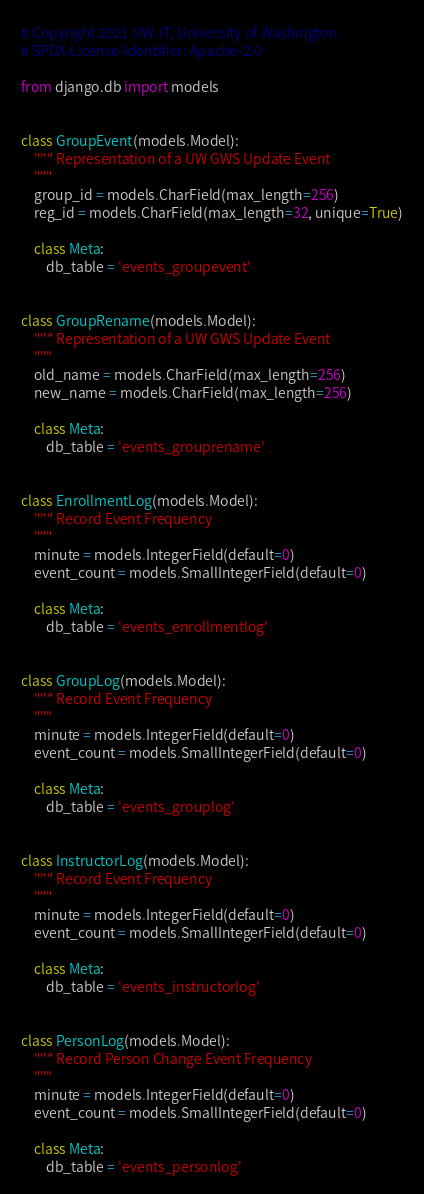<code> <loc_0><loc_0><loc_500><loc_500><_Python_># Copyright 2021 UW-IT, University of Washington
# SPDX-License-Identifier: Apache-2.0

from django.db import models


class GroupEvent(models.Model):
    """ Representation of a UW GWS Update Event
    """
    group_id = models.CharField(max_length=256)
    reg_id = models.CharField(max_length=32, unique=True)

    class Meta:
        db_table = 'events_groupevent'


class GroupRename(models.Model):
    """ Representation of a UW GWS Update Event
    """
    old_name = models.CharField(max_length=256)
    new_name = models.CharField(max_length=256)

    class Meta:
        db_table = 'events_grouprename'


class EnrollmentLog(models.Model):
    """ Record Event Frequency
    """
    minute = models.IntegerField(default=0)
    event_count = models.SmallIntegerField(default=0)

    class Meta:
        db_table = 'events_enrollmentlog'


class GroupLog(models.Model):
    """ Record Event Frequency
    """
    minute = models.IntegerField(default=0)
    event_count = models.SmallIntegerField(default=0)

    class Meta:
        db_table = 'events_grouplog'


class InstructorLog(models.Model):
    """ Record Event Frequency
    """
    minute = models.IntegerField(default=0)
    event_count = models.SmallIntegerField(default=0)

    class Meta:
        db_table = 'events_instructorlog'


class PersonLog(models.Model):
    """ Record Person Change Event Frequency
    """
    minute = models.IntegerField(default=0)
    event_count = models.SmallIntegerField(default=0)

    class Meta:
        db_table = 'events_personlog'
</code> 